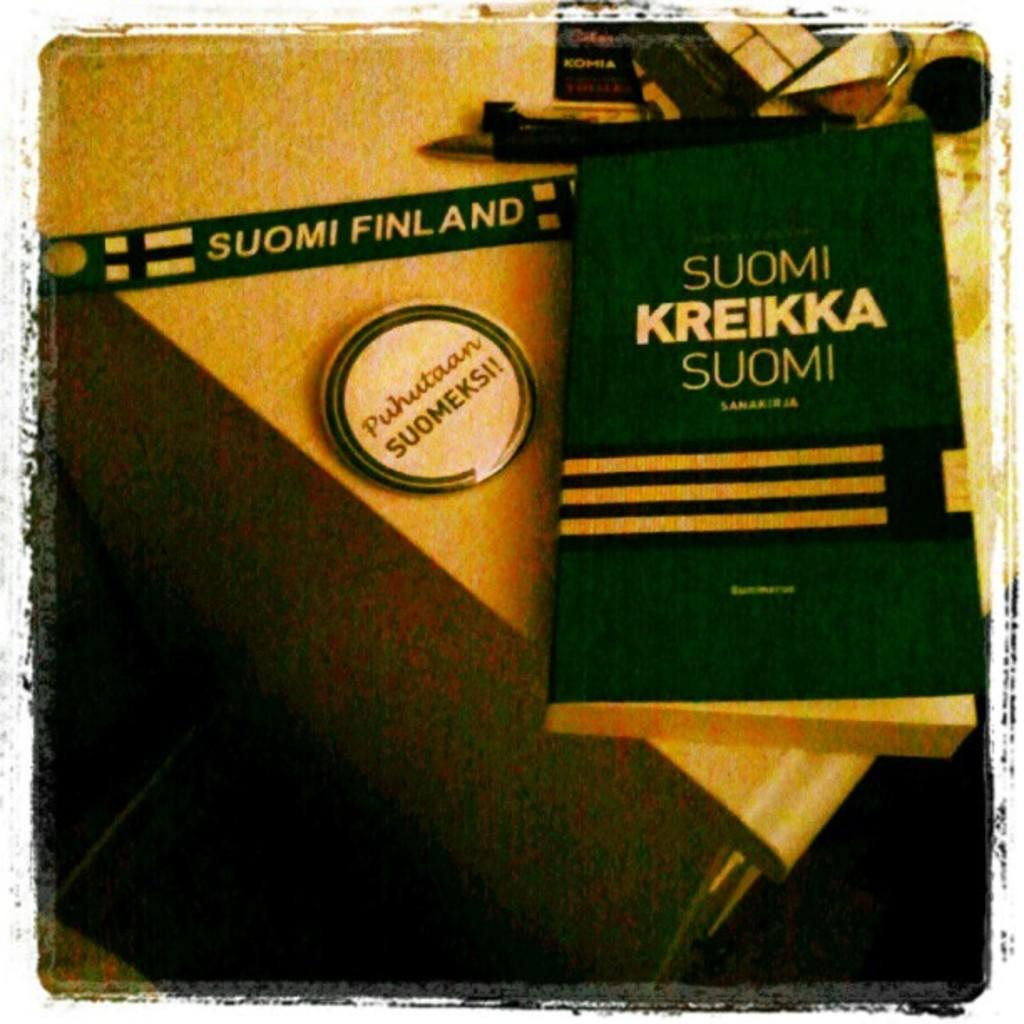<image>
Offer a succinct explanation of the picture presented. A button that says Puhutaan Suomeksi sits next to a book. 